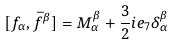Convert formula to latex. <formula><loc_0><loc_0><loc_500><loc_500>[ f _ { \alpha } , \bar { f } ^ { \beta } ] = M _ { \alpha } ^ { \beta } + \frac { 3 } { 2 } i e _ { 7 } \delta _ { \alpha } ^ { \beta }</formula> 